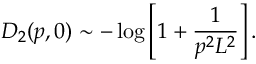<formula> <loc_0><loc_0><loc_500><loc_500>D _ { 2 } ( p , 0 ) \sim - \log \left [ 1 + \frac { 1 } { p ^ { 2 } L ^ { 2 } } \right ] .</formula> 